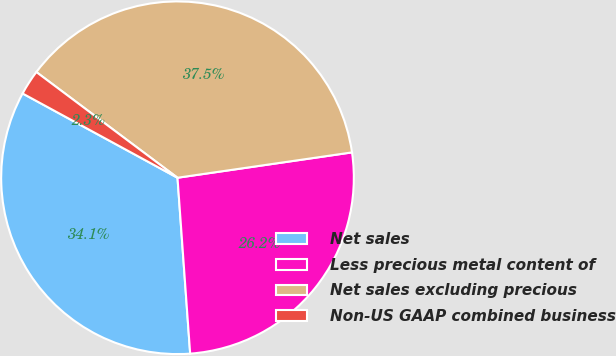Convert chart to OTSL. <chart><loc_0><loc_0><loc_500><loc_500><pie_chart><fcel>Net sales<fcel>Less precious metal content of<fcel>Net sales excluding precious<fcel>Non-US GAAP combined business<nl><fcel>34.07%<fcel>26.15%<fcel>37.47%<fcel>2.3%<nl></chart> 